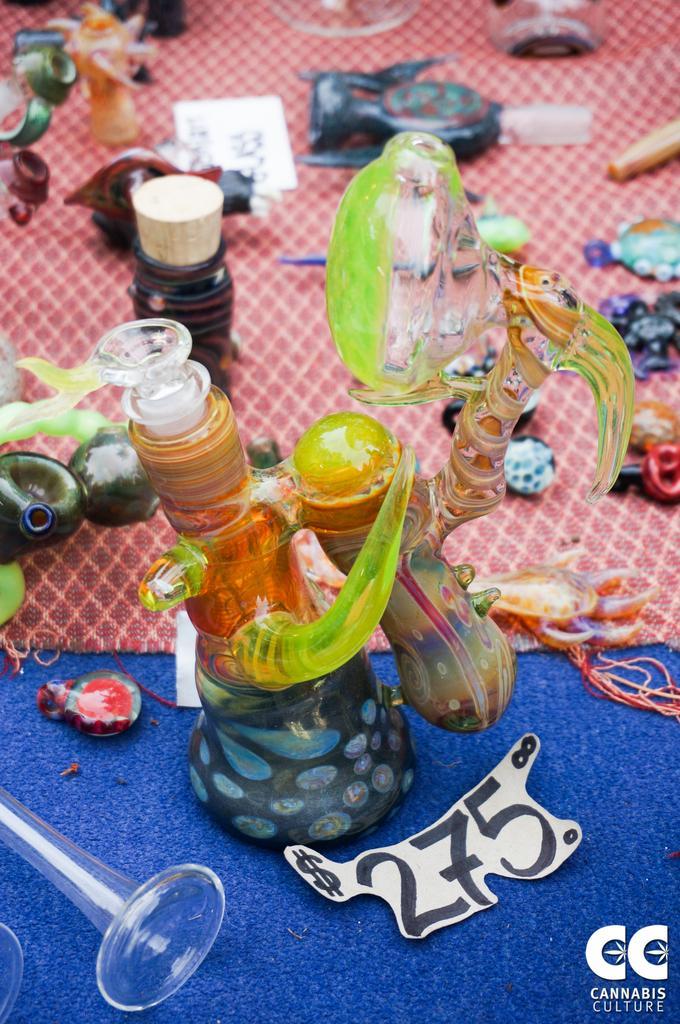Describe this image in one or two sentences. In this image we can see there are some toys, bottle, ball, glass and some other objects on the floor. 